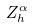<formula> <loc_0><loc_0><loc_500><loc_500>Z _ { h } ^ { \alpha }</formula> 